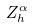<formula> <loc_0><loc_0><loc_500><loc_500>Z _ { h } ^ { \alpha }</formula> 